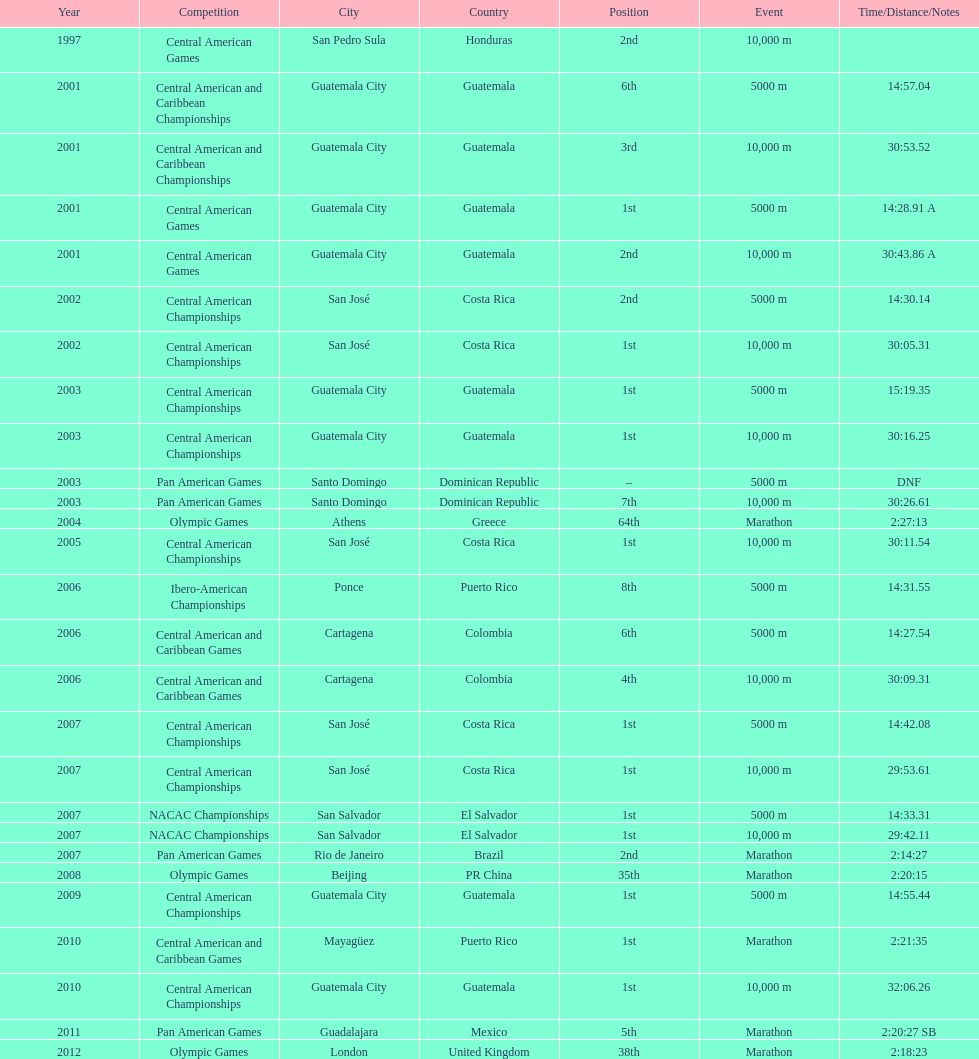Tell me the number of times they competed in guatamala. 5. 